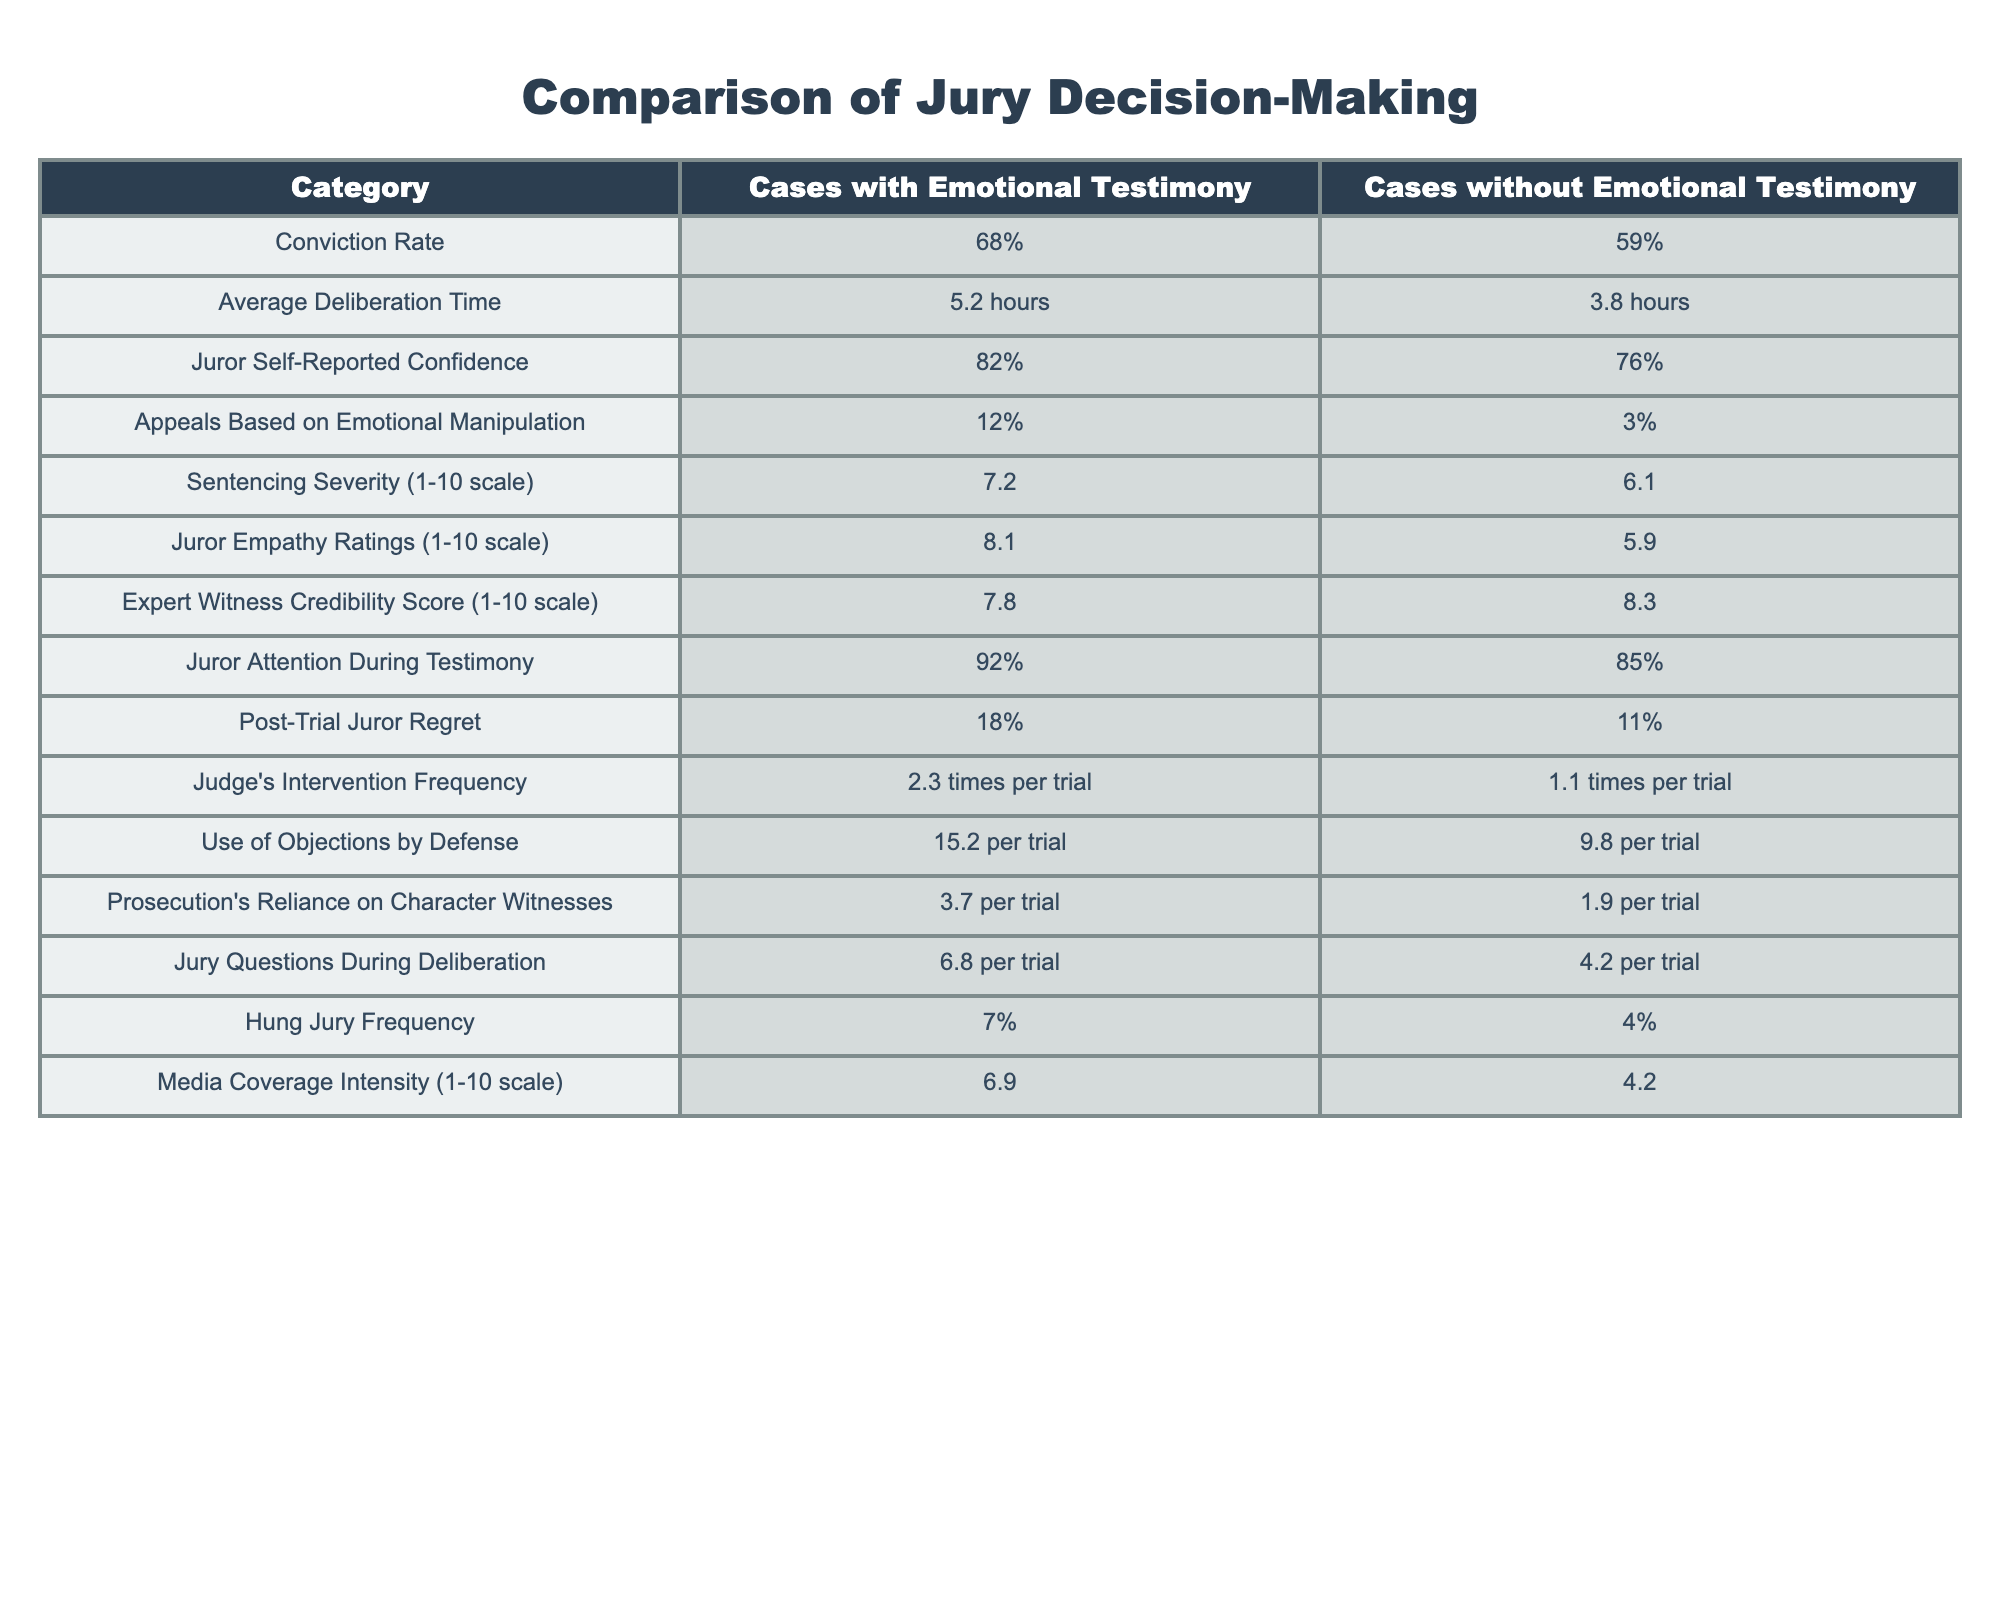What is the conviction rate for cases with emotional testimony? The conviction rate for cases with emotional testimony is directly listed in the table as 68%.
Answer: 68% What is the average deliberation time for cases without emotional testimony? The average deliberation time for cases without emotional testimony is clearly stated in the table as 3.8 hours.
Answer: 3.8 hours What is the difference in juror self-reported confidence between cases with and without emotional testimony? The self-reported confidence for cases with emotional testimony is 82% and for cases without is 76%. The difference is 82% - 76% = 6%.
Answer: 6% Is the hung jury frequency higher in cases with emotional testimony compared to cases without? The hung jury frequency for cases with emotional testimony is 7% while for cases without it is 4%. Since 7% is greater than 4%, the answer is yes.
Answer: Yes Which type of cases has a higher average severity in sentencing, and by how much? The average sentencing severity for cases with emotional testimony is 7.2 and for cases without is 6.1. The difference is 7.2 - 6.1 = 1.1. Thus, cases with emotional testimony have higher severity by 1.1.
Answer: 1.1 How does the expert witness credibility score differ between the two types of cases? In the table, the expert witness credibility score for cases with emotional testimony is 7.8, while for those without, it is 8.3. The difference is 7.8 - 8.3 = -0.5, indicating that cases without emotional testimony have a higher score.
Answer: -0.5 What is the average juror empathy rating for both types of cases? The average juror empathy rating is 8.1 for cases with emotional testimony and 5.9 for cases without emotional testimony, as shown in the table.
Answer: 8.1 for cases with emotional testimony, 5.9 for cases without In how many more times do judges intervene during trials that involve emotional testimony compared to those that do not? The frequency of judges' interventions in cases with emotional testimony is 2.3 times per trial, while for cases without, it is 1.1 times. The difference is 2.3 - 1.1 = 1.2 times, indicating judges intervene 1.2 more times.
Answer: 1.2 times Is there a notable difference in media coverage intensity between the two case types, and if so, what is it? The media coverage intensity for cases with emotional testimony is rated at 6.9 while for those without is 4.2. The difference of 6.9 - 4.2 = 2.7 indicates notable higher media coverage intensity for emotional testimony cases.
Answer: 2.7 